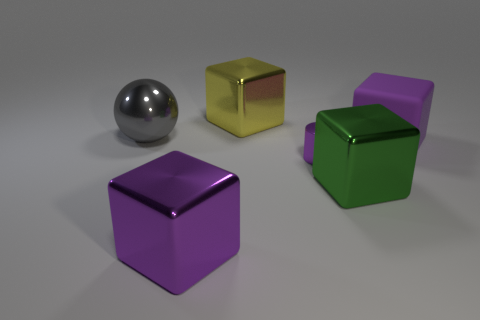Add 3 small things. How many objects exist? 9 Subtract all big yellow cubes. How many cubes are left? 3 Subtract all yellow blocks. How many blocks are left? 3 Subtract all blocks. How many objects are left? 2 Subtract 1 blocks. How many blocks are left? 3 Subtract 0 yellow cylinders. How many objects are left? 6 Subtract all brown cubes. Subtract all blue cylinders. How many cubes are left? 4 Subtract all brown balls. How many purple cubes are left? 2 Subtract all big rubber blocks. Subtract all tiny red rubber cubes. How many objects are left? 5 Add 6 big gray metal objects. How many big gray metal objects are left? 7 